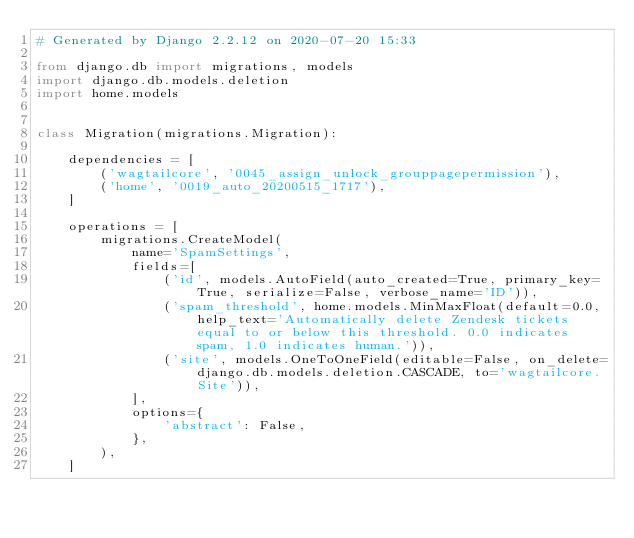Convert code to text. <code><loc_0><loc_0><loc_500><loc_500><_Python_># Generated by Django 2.2.12 on 2020-07-20 15:33

from django.db import migrations, models
import django.db.models.deletion
import home.models


class Migration(migrations.Migration):

    dependencies = [
        ('wagtailcore', '0045_assign_unlock_grouppagepermission'),
        ('home', '0019_auto_20200515_1717'),
    ]

    operations = [
        migrations.CreateModel(
            name='SpamSettings',
            fields=[
                ('id', models.AutoField(auto_created=True, primary_key=True, serialize=False, verbose_name='ID')),
                ('spam_threshold', home.models.MinMaxFloat(default=0.0, help_text='Automatically delete Zendesk tickets equal to or below this threshold. 0.0 indicates spam, 1.0 indicates human.')),
                ('site', models.OneToOneField(editable=False, on_delete=django.db.models.deletion.CASCADE, to='wagtailcore.Site')),
            ],
            options={
                'abstract': False,
            },
        ),
    ]
</code> 